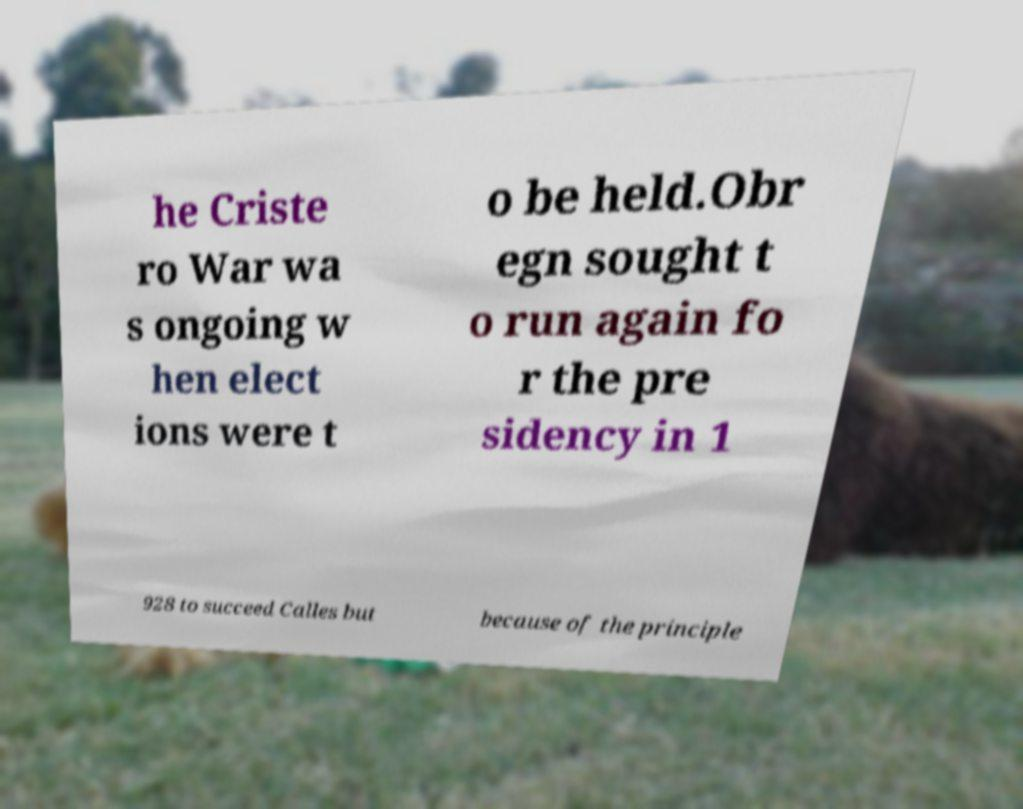Please read and relay the text visible in this image. What does it say? he Criste ro War wa s ongoing w hen elect ions were t o be held.Obr egn sought t o run again fo r the pre sidency in 1 928 to succeed Calles but because of the principle 